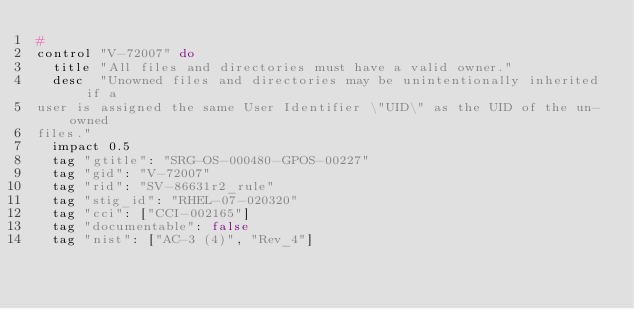<code> <loc_0><loc_0><loc_500><loc_500><_Ruby_>#
control "V-72007" do
  title "All files and directories must have a valid owner."
  desc  "Unowned files and directories may be unintentionally inherited if a
user is assigned the same User Identifier \"UID\" as the UID of the un-owned
files."
  impact 0.5
  tag "gtitle": "SRG-OS-000480-GPOS-00227"
  tag "gid": "V-72007"
  tag "rid": "SV-86631r2_rule"
  tag "stig_id": "RHEL-07-020320"
  tag "cci": ["CCI-002165"]
  tag "documentable": false
  tag "nist": ["AC-3 (4)", "Rev_4"]</code> 